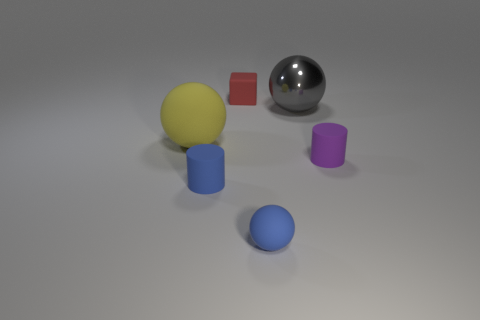Are there any red matte cubes that are to the left of the tiny matte thing that is behind the yellow rubber thing?
Give a very brief answer. No. What is the material of the large yellow sphere?
Ensure brevity in your answer.  Rubber. Are the tiny thing that is behind the gray metal ball and the thing that is right of the gray metal thing made of the same material?
Ensure brevity in your answer.  Yes. Is there anything else that is the same color as the metallic thing?
Offer a terse response. No. What color is the other small rubber object that is the same shape as the purple rubber object?
Offer a terse response. Blue. There is a object that is both behind the yellow ball and on the left side of the blue matte sphere; what is its size?
Make the answer very short. Small. There is a tiny matte thing behind the big yellow ball; does it have the same shape as the tiny thing that is right of the small rubber sphere?
Your response must be concise. No. What shape is the matte object that is the same color as the small ball?
Ensure brevity in your answer.  Cylinder. How many tiny cyan cylinders are the same material as the yellow ball?
Your response must be concise. 0. The tiny matte object that is both behind the blue rubber cylinder and left of the purple object has what shape?
Your answer should be compact. Cube. 